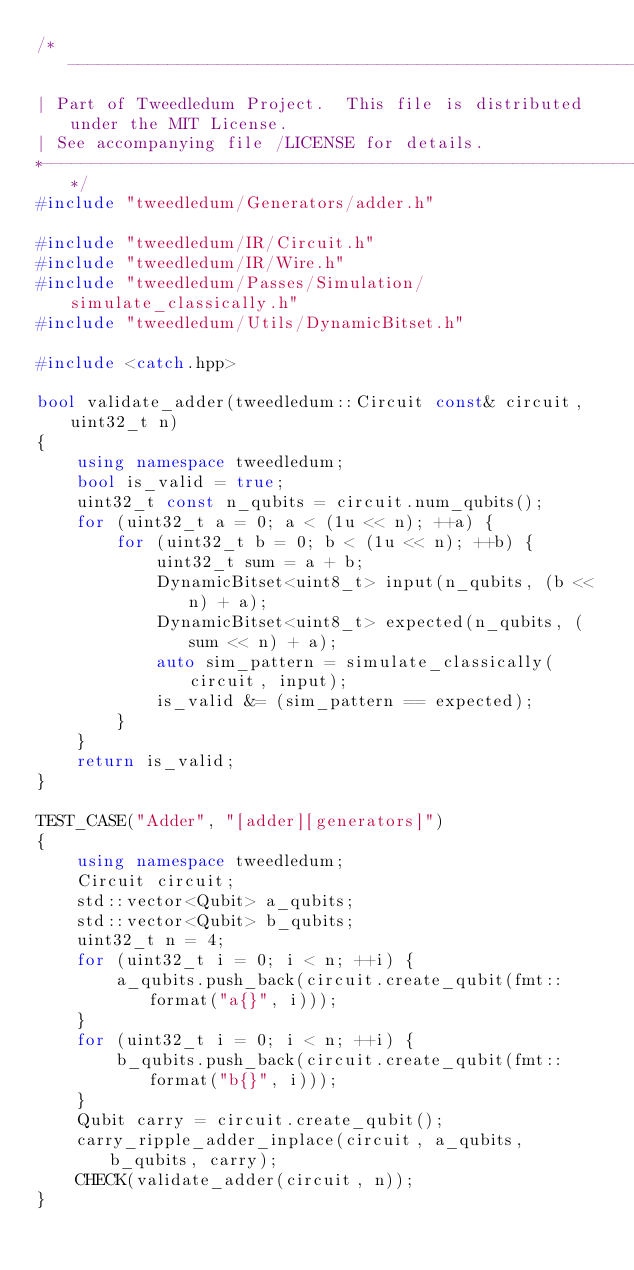Convert code to text. <code><loc_0><loc_0><loc_500><loc_500><_C++_>/*------------------------------------------------------------------------------
| Part of Tweedledum Project.  This file is distributed under the MIT License.
| See accompanying file /LICENSE for details.
*-----------------------------------------------------------------------------*/
#include "tweedledum/Generators/adder.h"

#include "tweedledum/IR/Circuit.h"
#include "tweedledum/IR/Wire.h"
#include "tweedledum/Passes/Simulation/simulate_classically.h"
#include "tweedledum/Utils/DynamicBitset.h"

#include <catch.hpp>

bool validate_adder(tweedledum::Circuit const& circuit, uint32_t n)
{
    using namespace tweedledum;
    bool is_valid = true;
    uint32_t const n_qubits = circuit.num_qubits();
    for (uint32_t a = 0; a < (1u << n); ++a) {
        for (uint32_t b = 0; b < (1u << n); ++b) {
            uint32_t sum = a + b;
            DynamicBitset<uint8_t> input(n_qubits, (b << n) + a);
            DynamicBitset<uint8_t> expected(n_qubits, (sum << n) + a);
            auto sim_pattern = simulate_classically(circuit, input);
            is_valid &= (sim_pattern == expected);
        }
    }
    return is_valid;
}

TEST_CASE("Adder", "[adder][generators]")
{
    using namespace tweedledum;
    Circuit circuit;
    std::vector<Qubit> a_qubits;
    std::vector<Qubit> b_qubits;
    uint32_t n = 4;
    for (uint32_t i = 0; i < n; ++i) {
        a_qubits.push_back(circuit.create_qubit(fmt::format("a{}", i)));
    }
    for (uint32_t i = 0; i < n; ++i) {
        b_qubits.push_back(circuit.create_qubit(fmt::format("b{}", i)));
    }
    Qubit carry = circuit.create_qubit();
    carry_ripple_adder_inplace(circuit, a_qubits, b_qubits, carry);
    CHECK(validate_adder(circuit, n));
}

</code> 